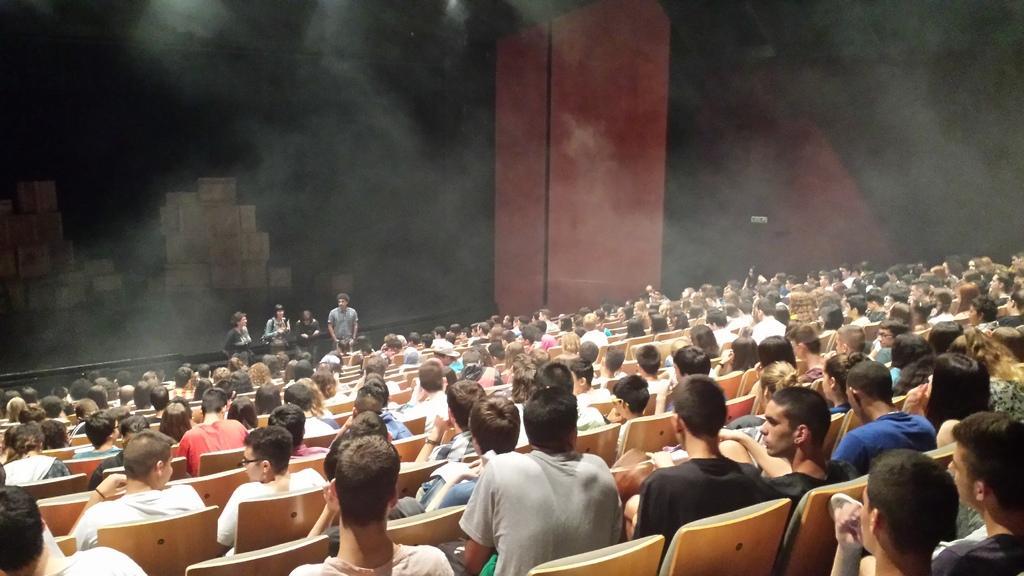Can you describe this image briefly? In this picture we can see a group of people sitting on chairs and in front of them we can see four people standing, boxes, pillar and some objects and in the background it is dark. 